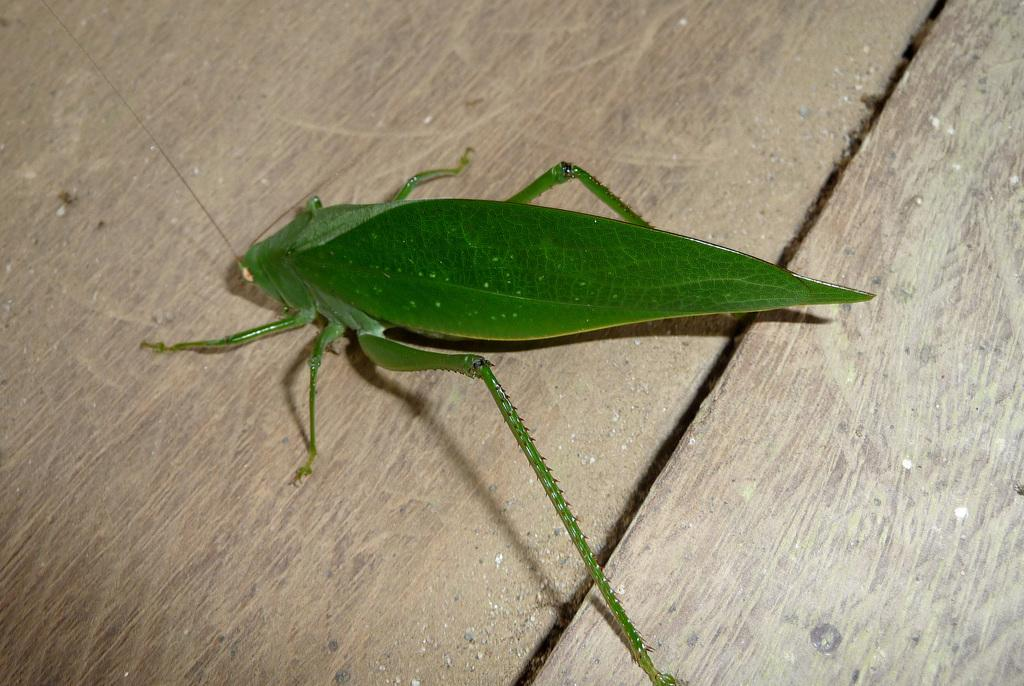What is the main object in the image? There is a table in the image. Is there anything else on the table besides the table itself? Yes, there is an insect on the table. What type of woman is sitting on the ice in the image? There is no woman or ice present in the image; it only features a table and an insect. 